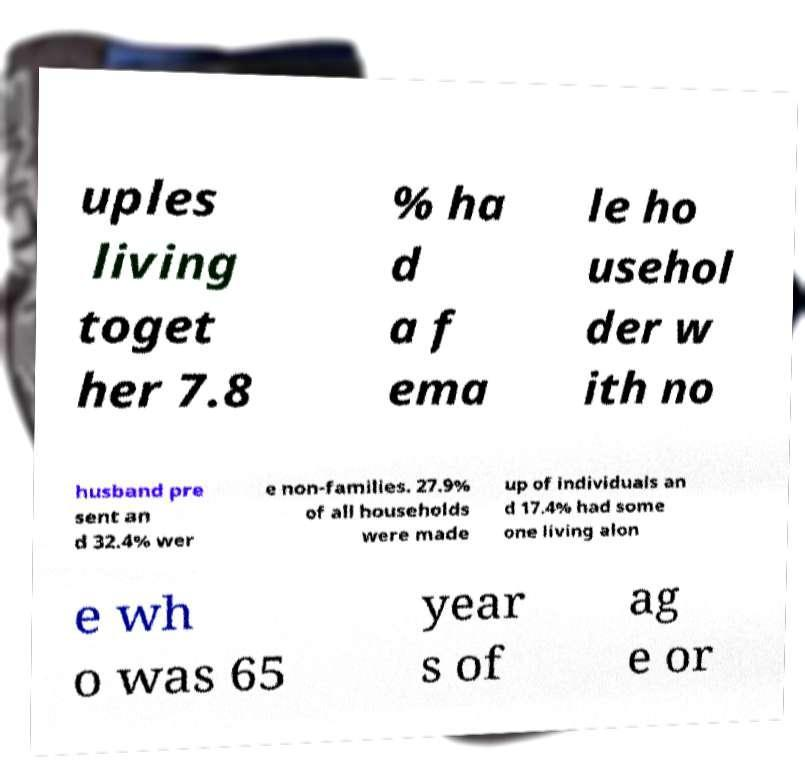Can you accurately transcribe the text from the provided image for me? uples living toget her 7.8 % ha d a f ema le ho usehol der w ith no husband pre sent an d 32.4% wer e non-families. 27.9% of all households were made up of individuals an d 17.4% had some one living alon e wh o was 65 year s of ag e or 